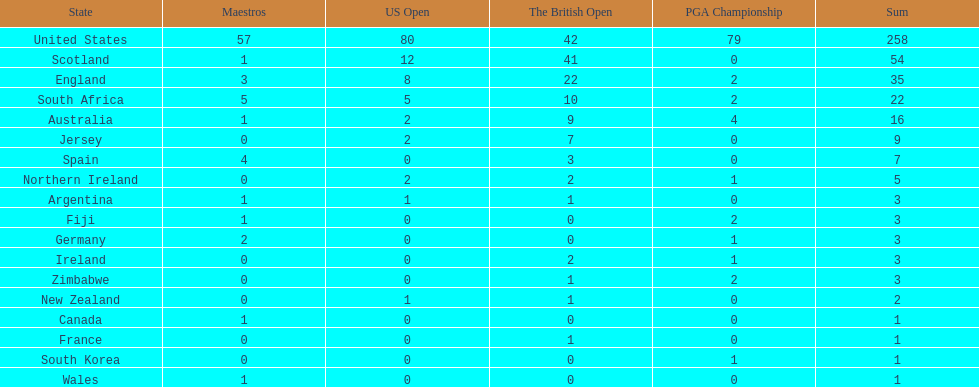Combined, how many winning golfers does england and wales have in the masters? 4. 